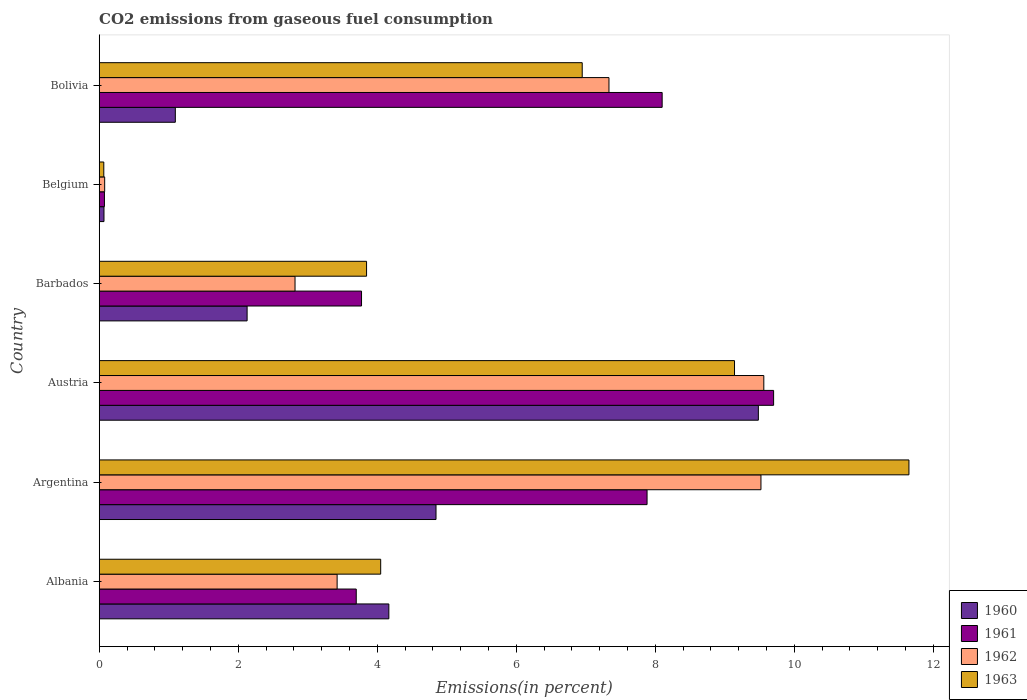How many groups of bars are there?
Provide a succinct answer. 6. Are the number of bars per tick equal to the number of legend labels?
Your response must be concise. Yes. How many bars are there on the 6th tick from the top?
Provide a short and direct response. 4. What is the label of the 3rd group of bars from the top?
Your answer should be compact. Barbados. What is the total CO2 emitted in 1960 in Albania?
Give a very brief answer. 4.17. Across all countries, what is the maximum total CO2 emitted in 1961?
Make the answer very short. 9.7. Across all countries, what is the minimum total CO2 emitted in 1961?
Keep it short and to the point. 0.08. What is the total total CO2 emitted in 1962 in the graph?
Your answer should be compact. 32.73. What is the difference between the total CO2 emitted in 1960 in Albania and that in Belgium?
Give a very brief answer. 4.1. What is the difference between the total CO2 emitted in 1961 in Albania and the total CO2 emitted in 1960 in Belgium?
Make the answer very short. 3.63. What is the average total CO2 emitted in 1963 per country?
Offer a very short reply. 5.95. What is the difference between the total CO2 emitted in 1960 and total CO2 emitted in 1962 in Albania?
Your answer should be very brief. 0.74. What is the ratio of the total CO2 emitted in 1960 in Austria to that in Barbados?
Offer a terse response. 4.46. What is the difference between the highest and the second highest total CO2 emitted in 1962?
Make the answer very short. 0.04. What is the difference between the highest and the lowest total CO2 emitted in 1961?
Provide a short and direct response. 9.63. In how many countries, is the total CO2 emitted in 1961 greater than the average total CO2 emitted in 1961 taken over all countries?
Keep it short and to the point. 3. Is the sum of the total CO2 emitted in 1961 in Albania and Austria greater than the maximum total CO2 emitted in 1962 across all countries?
Make the answer very short. Yes. Is it the case that in every country, the sum of the total CO2 emitted in 1960 and total CO2 emitted in 1961 is greater than the sum of total CO2 emitted in 1962 and total CO2 emitted in 1963?
Ensure brevity in your answer.  No. What does the 4th bar from the bottom in Albania represents?
Your answer should be very brief. 1963. Is it the case that in every country, the sum of the total CO2 emitted in 1963 and total CO2 emitted in 1960 is greater than the total CO2 emitted in 1961?
Your answer should be very brief. No. Are all the bars in the graph horizontal?
Ensure brevity in your answer.  Yes. How many legend labels are there?
Provide a succinct answer. 4. How are the legend labels stacked?
Offer a very short reply. Vertical. What is the title of the graph?
Offer a very short reply. CO2 emissions from gaseous fuel consumption. What is the label or title of the X-axis?
Provide a succinct answer. Emissions(in percent). What is the label or title of the Y-axis?
Keep it short and to the point. Country. What is the Emissions(in percent) in 1960 in Albania?
Provide a short and direct response. 4.17. What is the Emissions(in percent) in 1961 in Albania?
Your response must be concise. 3.7. What is the Emissions(in percent) of 1962 in Albania?
Give a very brief answer. 3.42. What is the Emissions(in percent) in 1963 in Albania?
Keep it short and to the point. 4.05. What is the Emissions(in percent) in 1960 in Argentina?
Ensure brevity in your answer.  4.85. What is the Emissions(in percent) of 1961 in Argentina?
Offer a terse response. 7.88. What is the Emissions(in percent) in 1962 in Argentina?
Ensure brevity in your answer.  9.52. What is the Emissions(in percent) of 1963 in Argentina?
Keep it short and to the point. 11.65. What is the Emissions(in percent) of 1960 in Austria?
Provide a short and direct response. 9.48. What is the Emissions(in percent) in 1961 in Austria?
Give a very brief answer. 9.7. What is the Emissions(in percent) in 1962 in Austria?
Your answer should be compact. 9.56. What is the Emissions(in percent) in 1963 in Austria?
Offer a very short reply. 9.14. What is the Emissions(in percent) of 1960 in Barbados?
Keep it short and to the point. 2.13. What is the Emissions(in percent) of 1961 in Barbados?
Offer a terse response. 3.77. What is the Emissions(in percent) in 1962 in Barbados?
Keep it short and to the point. 2.82. What is the Emissions(in percent) of 1963 in Barbados?
Keep it short and to the point. 3.85. What is the Emissions(in percent) of 1960 in Belgium?
Your response must be concise. 0.07. What is the Emissions(in percent) of 1961 in Belgium?
Give a very brief answer. 0.08. What is the Emissions(in percent) of 1962 in Belgium?
Provide a succinct answer. 0.08. What is the Emissions(in percent) of 1963 in Belgium?
Keep it short and to the point. 0.07. What is the Emissions(in percent) of 1960 in Bolivia?
Provide a succinct answer. 1.09. What is the Emissions(in percent) in 1961 in Bolivia?
Offer a very short reply. 8.1. What is the Emissions(in percent) in 1962 in Bolivia?
Make the answer very short. 7.33. What is the Emissions(in percent) of 1963 in Bolivia?
Provide a short and direct response. 6.95. Across all countries, what is the maximum Emissions(in percent) in 1960?
Your response must be concise. 9.48. Across all countries, what is the maximum Emissions(in percent) in 1961?
Your answer should be compact. 9.7. Across all countries, what is the maximum Emissions(in percent) of 1962?
Your answer should be compact. 9.56. Across all countries, what is the maximum Emissions(in percent) of 1963?
Your answer should be compact. 11.65. Across all countries, what is the minimum Emissions(in percent) of 1960?
Offer a terse response. 0.07. Across all countries, what is the minimum Emissions(in percent) of 1961?
Ensure brevity in your answer.  0.08. Across all countries, what is the minimum Emissions(in percent) of 1962?
Give a very brief answer. 0.08. Across all countries, what is the minimum Emissions(in percent) of 1963?
Provide a short and direct response. 0.07. What is the total Emissions(in percent) in 1960 in the graph?
Offer a terse response. 21.79. What is the total Emissions(in percent) in 1961 in the graph?
Ensure brevity in your answer.  33.23. What is the total Emissions(in percent) of 1962 in the graph?
Offer a very short reply. 32.73. What is the total Emissions(in percent) of 1963 in the graph?
Make the answer very short. 35.7. What is the difference between the Emissions(in percent) in 1960 in Albania and that in Argentina?
Offer a very short reply. -0.68. What is the difference between the Emissions(in percent) of 1961 in Albania and that in Argentina?
Your answer should be compact. -4.18. What is the difference between the Emissions(in percent) in 1962 in Albania and that in Argentina?
Provide a short and direct response. -6.1. What is the difference between the Emissions(in percent) of 1963 in Albania and that in Argentina?
Give a very brief answer. -7.6. What is the difference between the Emissions(in percent) of 1960 in Albania and that in Austria?
Your answer should be very brief. -5.32. What is the difference between the Emissions(in percent) in 1961 in Albania and that in Austria?
Provide a succinct answer. -6. What is the difference between the Emissions(in percent) in 1962 in Albania and that in Austria?
Give a very brief answer. -6.14. What is the difference between the Emissions(in percent) of 1963 in Albania and that in Austria?
Keep it short and to the point. -5.09. What is the difference between the Emissions(in percent) of 1960 in Albania and that in Barbados?
Your answer should be very brief. 2.04. What is the difference between the Emissions(in percent) of 1961 in Albania and that in Barbados?
Provide a short and direct response. -0.08. What is the difference between the Emissions(in percent) of 1962 in Albania and that in Barbados?
Your answer should be compact. 0.61. What is the difference between the Emissions(in percent) in 1963 in Albania and that in Barbados?
Provide a succinct answer. 0.2. What is the difference between the Emissions(in percent) of 1960 in Albania and that in Belgium?
Provide a short and direct response. 4.1. What is the difference between the Emissions(in percent) in 1961 in Albania and that in Belgium?
Your response must be concise. 3.62. What is the difference between the Emissions(in percent) in 1962 in Albania and that in Belgium?
Ensure brevity in your answer.  3.34. What is the difference between the Emissions(in percent) in 1963 in Albania and that in Belgium?
Ensure brevity in your answer.  3.98. What is the difference between the Emissions(in percent) in 1960 in Albania and that in Bolivia?
Provide a succinct answer. 3.07. What is the difference between the Emissions(in percent) of 1961 in Albania and that in Bolivia?
Provide a succinct answer. -4.4. What is the difference between the Emissions(in percent) of 1962 in Albania and that in Bolivia?
Offer a terse response. -3.91. What is the difference between the Emissions(in percent) in 1963 in Albania and that in Bolivia?
Keep it short and to the point. -2.9. What is the difference between the Emissions(in percent) of 1960 in Argentina and that in Austria?
Your response must be concise. -4.64. What is the difference between the Emissions(in percent) of 1961 in Argentina and that in Austria?
Ensure brevity in your answer.  -1.82. What is the difference between the Emissions(in percent) in 1962 in Argentina and that in Austria?
Offer a terse response. -0.04. What is the difference between the Emissions(in percent) in 1963 in Argentina and that in Austria?
Give a very brief answer. 2.51. What is the difference between the Emissions(in percent) in 1960 in Argentina and that in Barbados?
Provide a short and direct response. 2.72. What is the difference between the Emissions(in percent) in 1961 in Argentina and that in Barbados?
Keep it short and to the point. 4.11. What is the difference between the Emissions(in percent) in 1962 in Argentina and that in Barbados?
Your answer should be very brief. 6.7. What is the difference between the Emissions(in percent) in 1963 in Argentina and that in Barbados?
Give a very brief answer. 7.8. What is the difference between the Emissions(in percent) of 1960 in Argentina and that in Belgium?
Offer a very short reply. 4.78. What is the difference between the Emissions(in percent) of 1961 in Argentina and that in Belgium?
Make the answer very short. 7.81. What is the difference between the Emissions(in percent) in 1962 in Argentina and that in Belgium?
Provide a succinct answer. 9.44. What is the difference between the Emissions(in percent) in 1963 in Argentina and that in Belgium?
Offer a terse response. 11.58. What is the difference between the Emissions(in percent) in 1960 in Argentina and that in Bolivia?
Offer a very short reply. 3.75. What is the difference between the Emissions(in percent) of 1961 in Argentina and that in Bolivia?
Offer a terse response. -0.22. What is the difference between the Emissions(in percent) of 1962 in Argentina and that in Bolivia?
Your response must be concise. 2.19. What is the difference between the Emissions(in percent) in 1963 in Argentina and that in Bolivia?
Give a very brief answer. 4.7. What is the difference between the Emissions(in percent) of 1960 in Austria and that in Barbados?
Keep it short and to the point. 7.35. What is the difference between the Emissions(in percent) of 1961 in Austria and that in Barbados?
Provide a short and direct response. 5.93. What is the difference between the Emissions(in percent) in 1962 in Austria and that in Barbados?
Offer a terse response. 6.74. What is the difference between the Emissions(in percent) in 1963 in Austria and that in Barbados?
Offer a terse response. 5.29. What is the difference between the Emissions(in percent) in 1960 in Austria and that in Belgium?
Your response must be concise. 9.41. What is the difference between the Emissions(in percent) in 1961 in Austria and that in Belgium?
Your answer should be very brief. 9.63. What is the difference between the Emissions(in percent) of 1962 in Austria and that in Belgium?
Provide a succinct answer. 9.48. What is the difference between the Emissions(in percent) in 1963 in Austria and that in Belgium?
Ensure brevity in your answer.  9.07. What is the difference between the Emissions(in percent) of 1960 in Austria and that in Bolivia?
Your response must be concise. 8.39. What is the difference between the Emissions(in percent) in 1961 in Austria and that in Bolivia?
Ensure brevity in your answer.  1.6. What is the difference between the Emissions(in percent) in 1962 in Austria and that in Bolivia?
Ensure brevity in your answer.  2.23. What is the difference between the Emissions(in percent) of 1963 in Austria and that in Bolivia?
Give a very brief answer. 2.19. What is the difference between the Emissions(in percent) of 1960 in Barbados and that in Belgium?
Provide a short and direct response. 2.06. What is the difference between the Emissions(in percent) of 1961 in Barbados and that in Belgium?
Your answer should be compact. 3.7. What is the difference between the Emissions(in percent) of 1962 in Barbados and that in Belgium?
Your response must be concise. 2.74. What is the difference between the Emissions(in percent) in 1963 in Barbados and that in Belgium?
Provide a short and direct response. 3.78. What is the difference between the Emissions(in percent) in 1960 in Barbados and that in Bolivia?
Provide a succinct answer. 1.03. What is the difference between the Emissions(in percent) in 1961 in Barbados and that in Bolivia?
Keep it short and to the point. -4.33. What is the difference between the Emissions(in percent) in 1962 in Barbados and that in Bolivia?
Give a very brief answer. -4.52. What is the difference between the Emissions(in percent) in 1963 in Barbados and that in Bolivia?
Offer a terse response. -3.1. What is the difference between the Emissions(in percent) in 1960 in Belgium and that in Bolivia?
Ensure brevity in your answer.  -1.03. What is the difference between the Emissions(in percent) of 1961 in Belgium and that in Bolivia?
Give a very brief answer. -8.02. What is the difference between the Emissions(in percent) in 1962 in Belgium and that in Bolivia?
Your answer should be compact. -7.25. What is the difference between the Emissions(in percent) of 1963 in Belgium and that in Bolivia?
Offer a very short reply. -6.88. What is the difference between the Emissions(in percent) of 1960 in Albania and the Emissions(in percent) of 1961 in Argentina?
Ensure brevity in your answer.  -3.71. What is the difference between the Emissions(in percent) of 1960 in Albania and the Emissions(in percent) of 1962 in Argentina?
Give a very brief answer. -5.35. What is the difference between the Emissions(in percent) of 1960 in Albania and the Emissions(in percent) of 1963 in Argentina?
Keep it short and to the point. -7.48. What is the difference between the Emissions(in percent) in 1961 in Albania and the Emissions(in percent) in 1962 in Argentina?
Offer a very short reply. -5.82. What is the difference between the Emissions(in percent) of 1961 in Albania and the Emissions(in percent) of 1963 in Argentina?
Provide a succinct answer. -7.95. What is the difference between the Emissions(in percent) of 1962 in Albania and the Emissions(in percent) of 1963 in Argentina?
Your answer should be compact. -8.23. What is the difference between the Emissions(in percent) in 1960 in Albania and the Emissions(in percent) in 1961 in Austria?
Make the answer very short. -5.54. What is the difference between the Emissions(in percent) of 1960 in Albania and the Emissions(in percent) of 1962 in Austria?
Make the answer very short. -5.39. What is the difference between the Emissions(in percent) in 1960 in Albania and the Emissions(in percent) in 1963 in Austria?
Make the answer very short. -4.97. What is the difference between the Emissions(in percent) of 1961 in Albania and the Emissions(in percent) of 1962 in Austria?
Give a very brief answer. -5.86. What is the difference between the Emissions(in percent) in 1961 in Albania and the Emissions(in percent) in 1963 in Austria?
Give a very brief answer. -5.44. What is the difference between the Emissions(in percent) of 1962 in Albania and the Emissions(in percent) of 1963 in Austria?
Your answer should be compact. -5.72. What is the difference between the Emissions(in percent) of 1960 in Albania and the Emissions(in percent) of 1961 in Barbados?
Provide a short and direct response. 0.39. What is the difference between the Emissions(in percent) in 1960 in Albania and the Emissions(in percent) in 1962 in Barbados?
Provide a short and direct response. 1.35. What is the difference between the Emissions(in percent) in 1960 in Albania and the Emissions(in percent) in 1963 in Barbados?
Your answer should be compact. 0.32. What is the difference between the Emissions(in percent) of 1961 in Albania and the Emissions(in percent) of 1962 in Barbados?
Your response must be concise. 0.88. What is the difference between the Emissions(in percent) in 1961 in Albania and the Emissions(in percent) in 1963 in Barbados?
Keep it short and to the point. -0.15. What is the difference between the Emissions(in percent) in 1962 in Albania and the Emissions(in percent) in 1963 in Barbados?
Keep it short and to the point. -0.42. What is the difference between the Emissions(in percent) of 1960 in Albania and the Emissions(in percent) of 1961 in Belgium?
Ensure brevity in your answer.  4.09. What is the difference between the Emissions(in percent) in 1960 in Albania and the Emissions(in percent) in 1962 in Belgium?
Make the answer very short. 4.09. What is the difference between the Emissions(in percent) in 1960 in Albania and the Emissions(in percent) in 1963 in Belgium?
Your answer should be very brief. 4.1. What is the difference between the Emissions(in percent) of 1961 in Albania and the Emissions(in percent) of 1962 in Belgium?
Give a very brief answer. 3.62. What is the difference between the Emissions(in percent) of 1961 in Albania and the Emissions(in percent) of 1963 in Belgium?
Give a very brief answer. 3.63. What is the difference between the Emissions(in percent) of 1962 in Albania and the Emissions(in percent) of 1963 in Belgium?
Provide a succinct answer. 3.36. What is the difference between the Emissions(in percent) of 1960 in Albania and the Emissions(in percent) of 1961 in Bolivia?
Keep it short and to the point. -3.93. What is the difference between the Emissions(in percent) in 1960 in Albania and the Emissions(in percent) in 1962 in Bolivia?
Provide a succinct answer. -3.17. What is the difference between the Emissions(in percent) in 1960 in Albania and the Emissions(in percent) in 1963 in Bolivia?
Offer a very short reply. -2.78. What is the difference between the Emissions(in percent) of 1961 in Albania and the Emissions(in percent) of 1962 in Bolivia?
Provide a short and direct response. -3.64. What is the difference between the Emissions(in percent) of 1961 in Albania and the Emissions(in percent) of 1963 in Bolivia?
Provide a succinct answer. -3.25. What is the difference between the Emissions(in percent) in 1962 in Albania and the Emissions(in percent) in 1963 in Bolivia?
Offer a very short reply. -3.53. What is the difference between the Emissions(in percent) of 1960 in Argentina and the Emissions(in percent) of 1961 in Austria?
Offer a very short reply. -4.86. What is the difference between the Emissions(in percent) of 1960 in Argentina and the Emissions(in percent) of 1962 in Austria?
Provide a short and direct response. -4.72. What is the difference between the Emissions(in percent) of 1960 in Argentina and the Emissions(in percent) of 1963 in Austria?
Provide a short and direct response. -4.29. What is the difference between the Emissions(in percent) of 1961 in Argentina and the Emissions(in percent) of 1962 in Austria?
Provide a succinct answer. -1.68. What is the difference between the Emissions(in percent) in 1961 in Argentina and the Emissions(in percent) in 1963 in Austria?
Keep it short and to the point. -1.26. What is the difference between the Emissions(in percent) in 1962 in Argentina and the Emissions(in percent) in 1963 in Austria?
Give a very brief answer. 0.38. What is the difference between the Emissions(in percent) in 1960 in Argentina and the Emissions(in percent) in 1961 in Barbados?
Provide a succinct answer. 1.07. What is the difference between the Emissions(in percent) in 1960 in Argentina and the Emissions(in percent) in 1962 in Barbados?
Offer a very short reply. 2.03. What is the difference between the Emissions(in percent) in 1961 in Argentina and the Emissions(in percent) in 1962 in Barbados?
Your answer should be very brief. 5.06. What is the difference between the Emissions(in percent) of 1961 in Argentina and the Emissions(in percent) of 1963 in Barbados?
Ensure brevity in your answer.  4.04. What is the difference between the Emissions(in percent) of 1962 in Argentina and the Emissions(in percent) of 1963 in Barbados?
Your answer should be compact. 5.67. What is the difference between the Emissions(in percent) in 1960 in Argentina and the Emissions(in percent) in 1961 in Belgium?
Make the answer very short. 4.77. What is the difference between the Emissions(in percent) in 1960 in Argentina and the Emissions(in percent) in 1962 in Belgium?
Your answer should be compact. 4.77. What is the difference between the Emissions(in percent) in 1960 in Argentina and the Emissions(in percent) in 1963 in Belgium?
Ensure brevity in your answer.  4.78. What is the difference between the Emissions(in percent) in 1961 in Argentina and the Emissions(in percent) in 1962 in Belgium?
Keep it short and to the point. 7.8. What is the difference between the Emissions(in percent) in 1961 in Argentina and the Emissions(in percent) in 1963 in Belgium?
Offer a terse response. 7.82. What is the difference between the Emissions(in percent) of 1962 in Argentina and the Emissions(in percent) of 1963 in Belgium?
Offer a very short reply. 9.45. What is the difference between the Emissions(in percent) in 1960 in Argentina and the Emissions(in percent) in 1961 in Bolivia?
Offer a very short reply. -3.25. What is the difference between the Emissions(in percent) of 1960 in Argentina and the Emissions(in percent) of 1962 in Bolivia?
Ensure brevity in your answer.  -2.49. What is the difference between the Emissions(in percent) of 1960 in Argentina and the Emissions(in percent) of 1963 in Bolivia?
Make the answer very short. -2.1. What is the difference between the Emissions(in percent) in 1961 in Argentina and the Emissions(in percent) in 1962 in Bolivia?
Provide a short and direct response. 0.55. What is the difference between the Emissions(in percent) of 1961 in Argentina and the Emissions(in percent) of 1963 in Bolivia?
Your response must be concise. 0.93. What is the difference between the Emissions(in percent) in 1962 in Argentina and the Emissions(in percent) in 1963 in Bolivia?
Your response must be concise. 2.57. What is the difference between the Emissions(in percent) of 1960 in Austria and the Emissions(in percent) of 1961 in Barbados?
Offer a terse response. 5.71. What is the difference between the Emissions(in percent) of 1960 in Austria and the Emissions(in percent) of 1962 in Barbados?
Offer a very short reply. 6.67. What is the difference between the Emissions(in percent) in 1960 in Austria and the Emissions(in percent) in 1963 in Barbados?
Provide a succinct answer. 5.64. What is the difference between the Emissions(in percent) in 1961 in Austria and the Emissions(in percent) in 1962 in Barbados?
Keep it short and to the point. 6.88. What is the difference between the Emissions(in percent) of 1961 in Austria and the Emissions(in percent) of 1963 in Barbados?
Your response must be concise. 5.86. What is the difference between the Emissions(in percent) of 1962 in Austria and the Emissions(in percent) of 1963 in Barbados?
Provide a short and direct response. 5.71. What is the difference between the Emissions(in percent) of 1960 in Austria and the Emissions(in percent) of 1961 in Belgium?
Provide a short and direct response. 9.41. What is the difference between the Emissions(in percent) in 1960 in Austria and the Emissions(in percent) in 1962 in Belgium?
Ensure brevity in your answer.  9.4. What is the difference between the Emissions(in percent) of 1960 in Austria and the Emissions(in percent) of 1963 in Belgium?
Ensure brevity in your answer.  9.42. What is the difference between the Emissions(in percent) in 1961 in Austria and the Emissions(in percent) in 1962 in Belgium?
Your answer should be very brief. 9.62. What is the difference between the Emissions(in percent) of 1961 in Austria and the Emissions(in percent) of 1963 in Belgium?
Provide a short and direct response. 9.64. What is the difference between the Emissions(in percent) of 1962 in Austria and the Emissions(in percent) of 1963 in Belgium?
Ensure brevity in your answer.  9.49. What is the difference between the Emissions(in percent) in 1960 in Austria and the Emissions(in percent) in 1961 in Bolivia?
Make the answer very short. 1.38. What is the difference between the Emissions(in percent) of 1960 in Austria and the Emissions(in percent) of 1962 in Bolivia?
Offer a very short reply. 2.15. What is the difference between the Emissions(in percent) in 1960 in Austria and the Emissions(in percent) in 1963 in Bolivia?
Your response must be concise. 2.53. What is the difference between the Emissions(in percent) of 1961 in Austria and the Emissions(in percent) of 1962 in Bolivia?
Give a very brief answer. 2.37. What is the difference between the Emissions(in percent) of 1961 in Austria and the Emissions(in percent) of 1963 in Bolivia?
Offer a very short reply. 2.75. What is the difference between the Emissions(in percent) in 1962 in Austria and the Emissions(in percent) in 1963 in Bolivia?
Offer a very short reply. 2.61. What is the difference between the Emissions(in percent) in 1960 in Barbados and the Emissions(in percent) in 1961 in Belgium?
Make the answer very short. 2.05. What is the difference between the Emissions(in percent) of 1960 in Barbados and the Emissions(in percent) of 1962 in Belgium?
Keep it short and to the point. 2.05. What is the difference between the Emissions(in percent) in 1960 in Barbados and the Emissions(in percent) in 1963 in Belgium?
Provide a short and direct response. 2.06. What is the difference between the Emissions(in percent) in 1961 in Barbados and the Emissions(in percent) in 1962 in Belgium?
Offer a terse response. 3.7. What is the difference between the Emissions(in percent) in 1961 in Barbados and the Emissions(in percent) in 1963 in Belgium?
Your answer should be very brief. 3.71. What is the difference between the Emissions(in percent) of 1962 in Barbados and the Emissions(in percent) of 1963 in Belgium?
Your answer should be very brief. 2.75. What is the difference between the Emissions(in percent) in 1960 in Barbados and the Emissions(in percent) in 1961 in Bolivia?
Your response must be concise. -5.97. What is the difference between the Emissions(in percent) in 1960 in Barbados and the Emissions(in percent) in 1962 in Bolivia?
Your answer should be compact. -5.21. What is the difference between the Emissions(in percent) in 1960 in Barbados and the Emissions(in percent) in 1963 in Bolivia?
Your response must be concise. -4.82. What is the difference between the Emissions(in percent) of 1961 in Barbados and the Emissions(in percent) of 1962 in Bolivia?
Offer a very short reply. -3.56. What is the difference between the Emissions(in percent) of 1961 in Barbados and the Emissions(in percent) of 1963 in Bolivia?
Keep it short and to the point. -3.18. What is the difference between the Emissions(in percent) of 1962 in Barbados and the Emissions(in percent) of 1963 in Bolivia?
Give a very brief answer. -4.13. What is the difference between the Emissions(in percent) of 1960 in Belgium and the Emissions(in percent) of 1961 in Bolivia?
Offer a terse response. -8.03. What is the difference between the Emissions(in percent) of 1960 in Belgium and the Emissions(in percent) of 1962 in Bolivia?
Your answer should be compact. -7.26. What is the difference between the Emissions(in percent) of 1960 in Belgium and the Emissions(in percent) of 1963 in Bolivia?
Offer a very short reply. -6.88. What is the difference between the Emissions(in percent) of 1961 in Belgium and the Emissions(in percent) of 1962 in Bolivia?
Provide a short and direct response. -7.26. What is the difference between the Emissions(in percent) in 1961 in Belgium and the Emissions(in percent) in 1963 in Bolivia?
Offer a terse response. -6.87. What is the difference between the Emissions(in percent) of 1962 in Belgium and the Emissions(in percent) of 1963 in Bolivia?
Give a very brief answer. -6.87. What is the average Emissions(in percent) in 1960 per country?
Provide a succinct answer. 3.63. What is the average Emissions(in percent) in 1961 per country?
Give a very brief answer. 5.54. What is the average Emissions(in percent) of 1962 per country?
Offer a terse response. 5.46. What is the average Emissions(in percent) in 1963 per country?
Your answer should be compact. 5.95. What is the difference between the Emissions(in percent) of 1960 and Emissions(in percent) of 1961 in Albania?
Make the answer very short. 0.47. What is the difference between the Emissions(in percent) in 1960 and Emissions(in percent) in 1962 in Albania?
Ensure brevity in your answer.  0.74. What is the difference between the Emissions(in percent) in 1960 and Emissions(in percent) in 1963 in Albania?
Make the answer very short. 0.12. What is the difference between the Emissions(in percent) in 1961 and Emissions(in percent) in 1962 in Albania?
Give a very brief answer. 0.28. What is the difference between the Emissions(in percent) of 1961 and Emissions(in percent) of 1963 in Albania?
Your answer should be very brief. -0.35. What is the difference between the Emissions(in percent) of 1962 and Emissions(in percent) of 1963 in Albania?
Your response must be concise. -0.63. What is the difference between the Emissions(in percent) of 1960 and Emissions(in percent) of 1961 in Argentina?
Keep it short and to the point. -3.04. What is the difference between the Emissions(in percent) of 1960 and Emissions(in percent) of 1962 in Argentina?
Offer a very short reply. -4.67. What is the difference between the Emissions(in percent) in 1960 and Emissions(in percent) in 1963 in Argentina?
Make the answer very short. -6.8. What is the difference between the Emissions(in percent) of 1961 and Emissions(in percent) of 1962 in Argentina?
Make the answer very short. -1.64. What is the difference between the Emissions(in percent) of 1961 and Emissions(in percent) of 1963 in Argentina?
Give a very brief answer. -3.77. What is the difference between the Emissions(in percent) of 1962 and Emissions(in percent) of 1963 in Argentina?
Give a very brief answer. -2.13. What is the difference between the Emissions(in percent) of 1960 and Emissions(in percent) of 1961 in Austria?
Offer a very short reply. -0.22. What is the difference between the Emissions(in percent) in 1960 and Emissions(in percent) in 1962 in Austria?
Your response must be concise. -0.08. What is the difference between the Emissions(in percent) of 1960 and Emissions(in percent) of 1963 in Austria?
Make the answer very short. 0.34. What is the difference between the Emissions(in percent) in 1961 and Emissions(in percent) in 1962 in Austria?
Offer a terse response. 0.14. What is the difference between the Emissions(in percent) of 1961 and Emissions(in percent) of 1963 in Austria?
Keep it short and to the point. 0.56. What is the difference between the Emissions(in percent) of 1962 and Emissions(in percent) of 1963 in Austria?
Provide a short and direct response. 0.42. What is the difference between the Emissions(in percent) of 1960 and Emissions(in percent) of 1961 in Barbados?
Offer a terse response. -1.65. What is the difference between the Emissions(in percent) in 1960 and Emissions(in percent) in 1962 in Barbados?
Offer a very short reply. -0.69. What is the difference between the Emissions(in percent) in 1960 and Emissions(in percent) in 1963 in Barbados?
Make the answer very short. -1.72. What is the difference between the Emissions(in percent) of 1961 and Emissions(in percent) of 1962 in Barbados?
Provide a short and direct response. 0.96. What is the difference between the Emissions(in percent) of 1961 and Emissions(in percent) of 1963 in Barbados?
Ensure brevity in your answer.  -0.07. What is the difference between the Emissions(in percent) of 1962 and Emissions(in percent) of 1963 in Barbados?
Offer a terse response. -1.03. What is the difference between the Emissions(in percent) of 1960 and Emissions(in percent) of 1961 in Belgium?
Your response must be concise. -0.01. What is the difference between the Emissions(in percent) in 1960 and Emissions(in percent) in 1962 in Belgium?
Provide a succinct answer. -0.01. What is the difference between the Emissions(in percent) of 1960 and Emissions(in percent) of 1963 in Belgium?
Provide a succinct answer. 0. What is the difference between the Emissions(in percent) in 1961 and Emissions(in percent) in 1962 in Belgium?
Your response must be concise. -0. What is the difference between the Emissions(in percent) of 1961 and Emissions(in percent) of 1963 in Belgium?
Keep it short and to the point. 0.01. What is the difference between the Emissions(in percent) of 1962 and Emissions(in percent) of 1963 in Belgium?
Provide a succinct answer. 0.01. What is the difference between the Emissions(in percent) of 1960 and Emissions(in percent) of 1961 in Bolivia?
Offer a very short reply. -7. What is the difference between the Emissions(in percent) in 1960 and Emissions(in percent) in 1962 in Bolivia?
Make the answer very short. -6.24. What is the difference between the Emissions(in percent) of 1960 and Emissions(in percent) of 1963 in Bolivia?
Keep it short and to the point. -5.85. What is the difference between the Emissions(in percent) in 1961 and Emissions(in percent) in 1962 in Bolivia?
Provide a succinct answer. 0.77. What is the difference between the Emissions(in percent) in 1961 and Emissions(in percent) in 1963 in Bolivia?
Offer a terse response. 1.15. What is the difference between the Emissions(in percent) of 1962 and Emissions(in percent) of 1963 in Bolivia?
Your answer should be compact. 0.38. What is the ratio of the Emissions(in percent) of 1960 in Albania to that in Argentina?
Ensure brevity in your answer.  0.86. What is the ratio of the Emissions(in percent) in 1961 in Albania to that in Argentina?
Your answer should be compact. 0.47. What is the ratio of the Emissions(in percent) in 1962 in Albania to that in Argentina?
Ensure brevity in your answer.  0.36. What is the ratio of the Emissions(in percent) in 1963 in Albania to that in Argentina?
Provide a short and direct response. 0.35. What is the ratio of the Emissions(in percent) of 1960 in Albania to that in Austria?
Your answer should be very brief. 0.44. What is the ratio of the Emissions(in percent) in 1961 in Albania to that in Austria?
Make the answer very short. 0.38. What is the ratio of the Emissions(in percent) of 1962 in Albania to that in Austria?
Provide a short and direct response. 0.36. What is the ratio of the Emissions(in percent) in 1963 in Albania to that in Austria?
Keep it short and to the point. 0.44. What is the ratio of the Emissions(in percent) in 1960 in Albania to that in Barbados?
Your answer should be compact. 1.96. What is the ratio of the Emissions(in percent) of 1961 in Albania to that in Barbados?
Your answer should be very brief. 0.98. What is the ratio of the Emissions(in percent) in 1962 in Albania to that in Barbados?
Your response must be concise. 1.22. What is the ratio of the Emissions(in percent) of 1963 in Albania to that in Barbados?
Your response must be concise. 1.05. What is the ratio of the Emissions(in percent) in 1960 in Albania to that in Belgium?
Offer a very short reply. 60.82. What is the ratio of the Emissions(in percent) in 1961 in Albania to that in Belgium?
Offer a terse response. 49.25. What is the ratio of the Emissions(in percent) in 1962 in Albania to that in Belgium?
Your answer should be very brief. 43.61. What is the ratio of the Emissions(in percent) in 1963 in Albania to that in Belgium?
Your answer should be compact. 61.48. What is the ratio of the Emissions(in percent) in 1960 in Albania to that in Bolivia?
Your answer should be compact. 3.81. What is the ratio of the Emissions(in percent) of 1961 in Albania to that in Bolivia?
Provide a short and direct response. 0.46. What is the ratio of the Emissions(in percent) of 1962 in Albania to that in Bolivia?
Your answer should be compact. 0.47. What is the ratio of the Emissions(in percent) in 1963 in Albania to that in Bolivia?
Offer a terse response. 0.58. What is the ratio of the Emissions(in percent) in 1960 in Argentina to that in Austria?
Offer a very short reply. 0.51. What is the ratio of the Emissions(in percent) of 1961 in Argentina to that in Austria?
Give a very brief answer. 0.81. What is the ratio of the Emissions(in percent) in 1963 in Argentina to that in Austria?
Offer a very short reply. 1.27. What is the ratio of the Emissions(in percent) of 1960 in Argentina to that in Barbados?
Offer a very short reply. 2.28. What is the ratio of the Emissions(in percent) in 1961 in Argentina to that in Barbados?
Your response must be concise. 2.09. What is the ratio of the Emissions(in percent) in 1962 in Argentina to that in Barbados?
Offer a very short reply. 3.38. What is the ratio of the Emissions(in percent) in 1963 in Argentina to that in Barbados?
Your response must be concise. 3.03. What is the ratio of the Emissions(in percent) in 1960 in Argentina to that in Belgium?
Make the answer very short. 70.73. What is the ratio of the Emissions(in percent) in 1961 in Argentina to that in Belgium?
Offer a very short reply. 104.97. What is the ratio of the Emissions(in percent) in 1962 in Argentina to that in Belgium?
Make the answer very short. 121.3. What is the ratio of the Emissions(in percent) in 1963 in Argentina to that in Belgium?
Give a very brief answer. 176.86. What is the ratio of the Emissions(in percent) in 1960 in Argentina to that in Bolivia?
Your answer should be compact. 4.43. What is the ratio of the Emissions(in percent) of 1961 in Argentina to that in Bolivia?
Keep it short and to the point. 0.97. What is the ratio of the Emissions(in percent) in 1962 in Argentina to that in Bolivia?
Offer a terse response. 1.3. What is the ratio of the Emissions(in percent) in 1963 in Argentina to that in Bolivia?
Provide a succinct answer. 1.68. What is the ratio of the Emissions(in percent) of 1960 in Austria to that in Barbados?
Your answer should be very brief. 4.46. What is the ratio of the Emissions(in percent) of 1961 in Austria to that in Barbados?
Your answer should be very brief. 2.57. What is the ratio of the Emissions(in percent) in 1962 in Austria to that in Barbados?
Provide a succinct answer. 3.39. What is the ratio of the Emissions(in percent) in 1963 in Austria to that in Barbados?
Give a very brief answer. 2.38. What is the ratio of the Emissions(in percent) of 1960 in Austria to that in Belgium?
Offer a very short reply. 138.42. What is the ratio of the Emissions(in percent) in 1961 in Austria to that in Belgium?
Provide a succinct answer. 129.21. What is the ratio of the Emissions(in percent) in 1962 in Austria to that in Belgium?
Your answer should be very brief. 121.82. What is the ratio of the Emissions(in percent) of 1963 in Austria to that in Belgium?
Offer a very short reply. 138.76. What is the ratio of the Emissions(in percent) in 1960 in Austria to that in Bolivia?
Your answer should be very brief. 8.66. What is the ratio of the Emissions(in percent) in 1961 in Austria to that in Bolivia?
Make the answer very short. 1.2. What is the ratio of the Emissions(in percent) of 1962 in Austria to that in Bolivia?
Your response must be concise. 1.3. What is the ratio of the Emissions(in percent) of 1963 in Austria to that in Bolivia?
Provide a succinct answer. 1.32. What is the ratio of the Emissions(in percent) of 1960 in Barbados to that in Belgium?
Your answer should be compact. 31.06. What is the ratio of the Emissions(in percent) in 1961 in Barbados to that in Belgium?
Your answer should be compact. 50.26. What is the ratio of the Emissions(in percent) of 1962 in Barbados to that in Belgium?
Provide a short and direct response. 35.89. What is the ratio of the Emissions(in percent) in 1963 in Barbados to that in Belgium?
Ensure brevity in your answer.  58.39. What is the ratio of the Emissions(in percent) of 1960 in Barbados to that in Bolivia?
Offer a very short reply. 1.94. What is the ratio of the Emissions(in percent) in 1961 in Barbados to that in Bolivia?
Give a very brief answer. 0.47. What is the ratio of the Emissions(in percent) in 1962 in Barbados to that in Bolivia?
Keep it short and to the point. 0.38. What is the ratio of the Emissions(in percent) in 1963 in Barbados to that in Bolivia?
Provide a short and direct response. 0.55. What is the ratio of the Emissions(in percent) of 1960 in Belgium to that in Bolivia?
Keep it short and to the point. 0.06. What is the ratio of the Emissions(in percent) in 1961 in Belgium to that in Bolivia?
Provide a short and direct response. 0.01. What is the ratio of the Emissions(in percent) in 1962 in Belgium to that in Bolivia?
Keep it short and to the point. 0.01. What is the ratio of the Emissions(in percent) in 1963 in Belgium to that in Bolivia?
Give a very brief answer. 0.01. What is the difference between the highest and the second highest Emissions(in percent) of 1960?
Your answer should be compact. 4.64. What is the difference between the highest and the second highest Emissions(in percent) of 1961?
Offer a very short reply. 1.6. What is the difference between the highest and the second highest Emissions(in percent) in 1962?
Offer a very short reply. 0.04. What is the difference between the highest and the second highest Emissions(in percent) in 1963?
Keep it short and to the point. 2.51. What is the difference between the highest and the lowest Emissions(in percent) in 1960?
Offer a terse response. 9.41. What is the difference between the highest and the lowest Emissions(in percent) in 1961?
Offer a very short reply. 9.63. What is the difference between the highest and the lowest Emissions(in percent) of 1962?
Provide a succinct answer. 9.48. What is the difference between the highest and the lowest Emissions(in percent) in 1963?
Give a very brief answer. 11.58. 